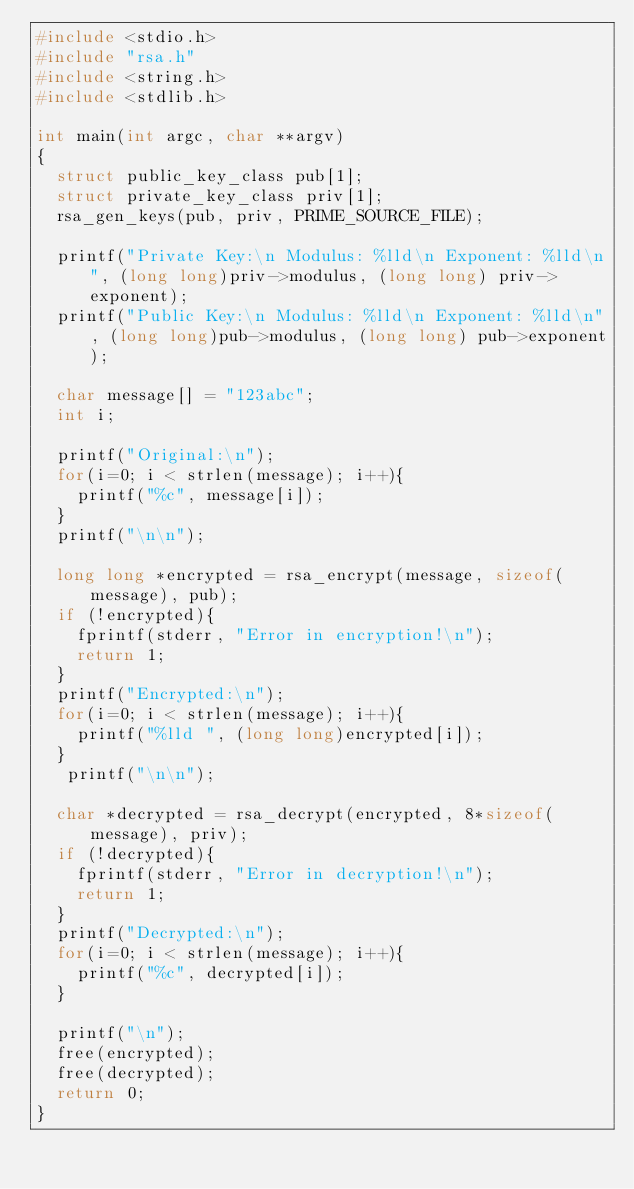Convert code to text. <code><loc_0><loc_0><loc_500><loc_500><_C_>#include <stdio.h>
#include "rsa.h"
#include <string.h>
#include <stdlib.h>

int main(int argc, char **argv)
{
  struct public_key_class pub[1];
  struct private_key_class priv[1];
  rsa_gen_keys(pub, priv, PRIME_SOURCE_FILE);

  printf("Private Key:\n Modulus: %lld\n Exponent: %lld\n", (long long)priv->modulus, (long long) priv->exponent);
  printf("Public Key:\n Modulus: %lld\n Exponent: %lld\n", (long long)pub->modulus, (long long) pub->exponent);
  
  char message[] = "123abc";
  int i;

  printf("Original:\n");
  for(i=0; i < strlen(message); i++){
    printf("%c", message[i]);
  }  
  printf("\n\n");

  long long *encrypted = rsa_encrypt(message, sizeof(message), pub);
  if (!encrypted){
    fprintf(stderr, "Error in encryption!\n");
    return 1;
  }
  printf("Encrypted:\n");
  for(i=0; i < strlen(message); i++){
    printf("%lld ", (long long)encrypted[i]);
  }  
   printf("\n\n");

  char *decrypted = rsa_decrypt(encrypted, 8*sizeof(message), priv);
  if (!decrypted){
    fprintf(stderr, "Error in decryption!\n");
    return 1;
  }
  printf("Decrypted:\n");
  for(i=0; i < strlen(message); i++){
    printf("%c", decrypted[i]);
  }  
  
  printf("\n");
  free(encrypted);
  free(decrypted);
  return 0;
}
</code> 